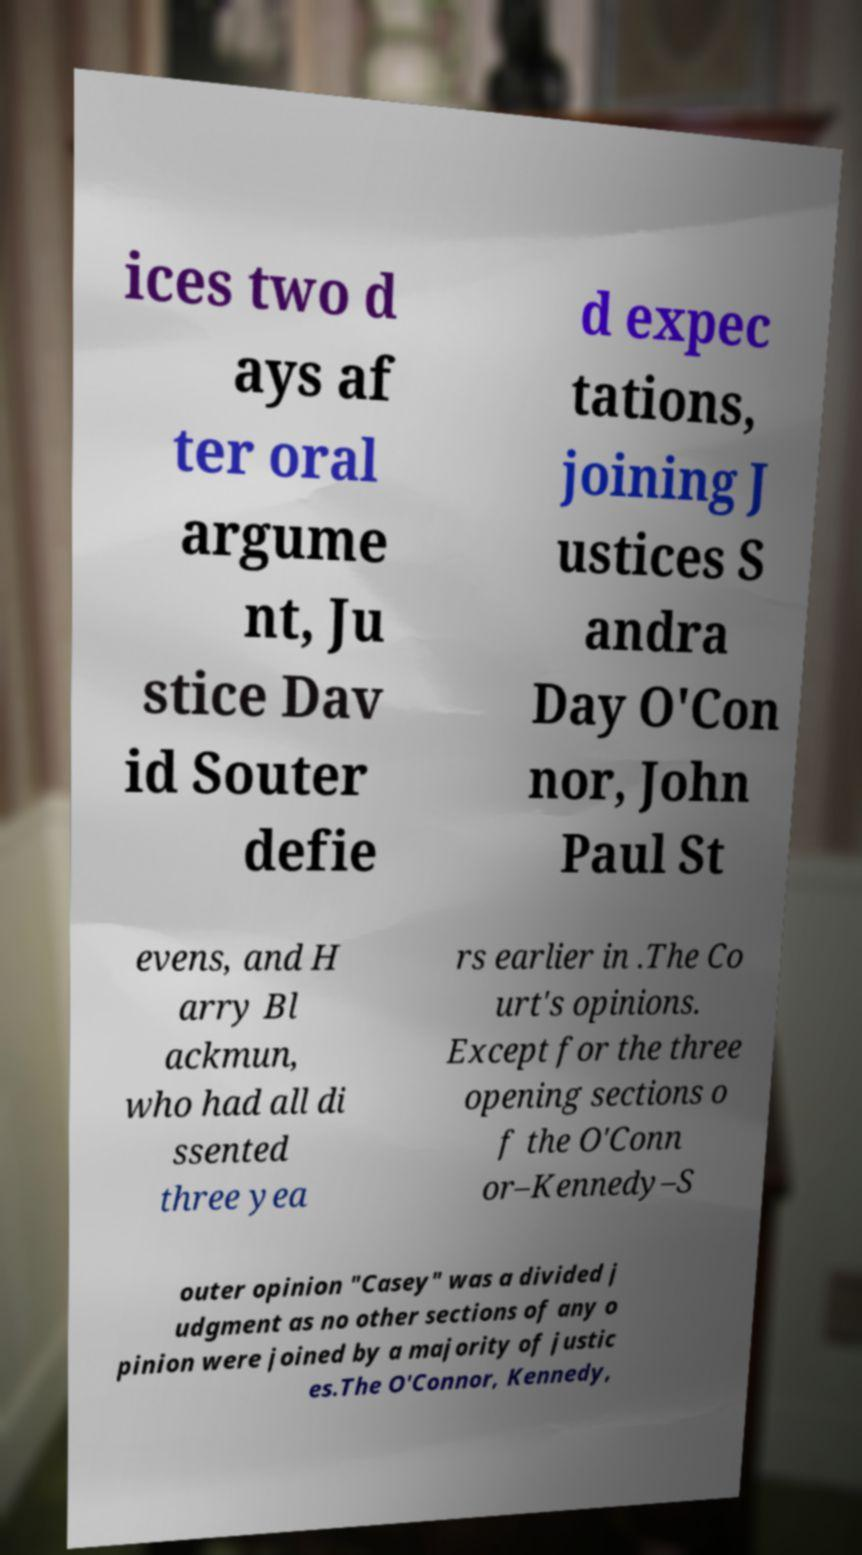Could you extract and type out the text from this image? ices two d ays af ter oral argume nt, Ju stice Dav id Souter defie d expec tations, joining J ustices S andra Day O'Con nor, John Paul St evens, and H arry Bl ackmun, who had all di ssented three yea rs earlier in .The Co urt's opinions. Except for the three opening sections o f the O'Conn or–Kennedy–S outer opinion "Casey" was a divided j udgment as no other sections of any o pinion were joined by a majority of justic es.The O'Connor, Kennedy, 